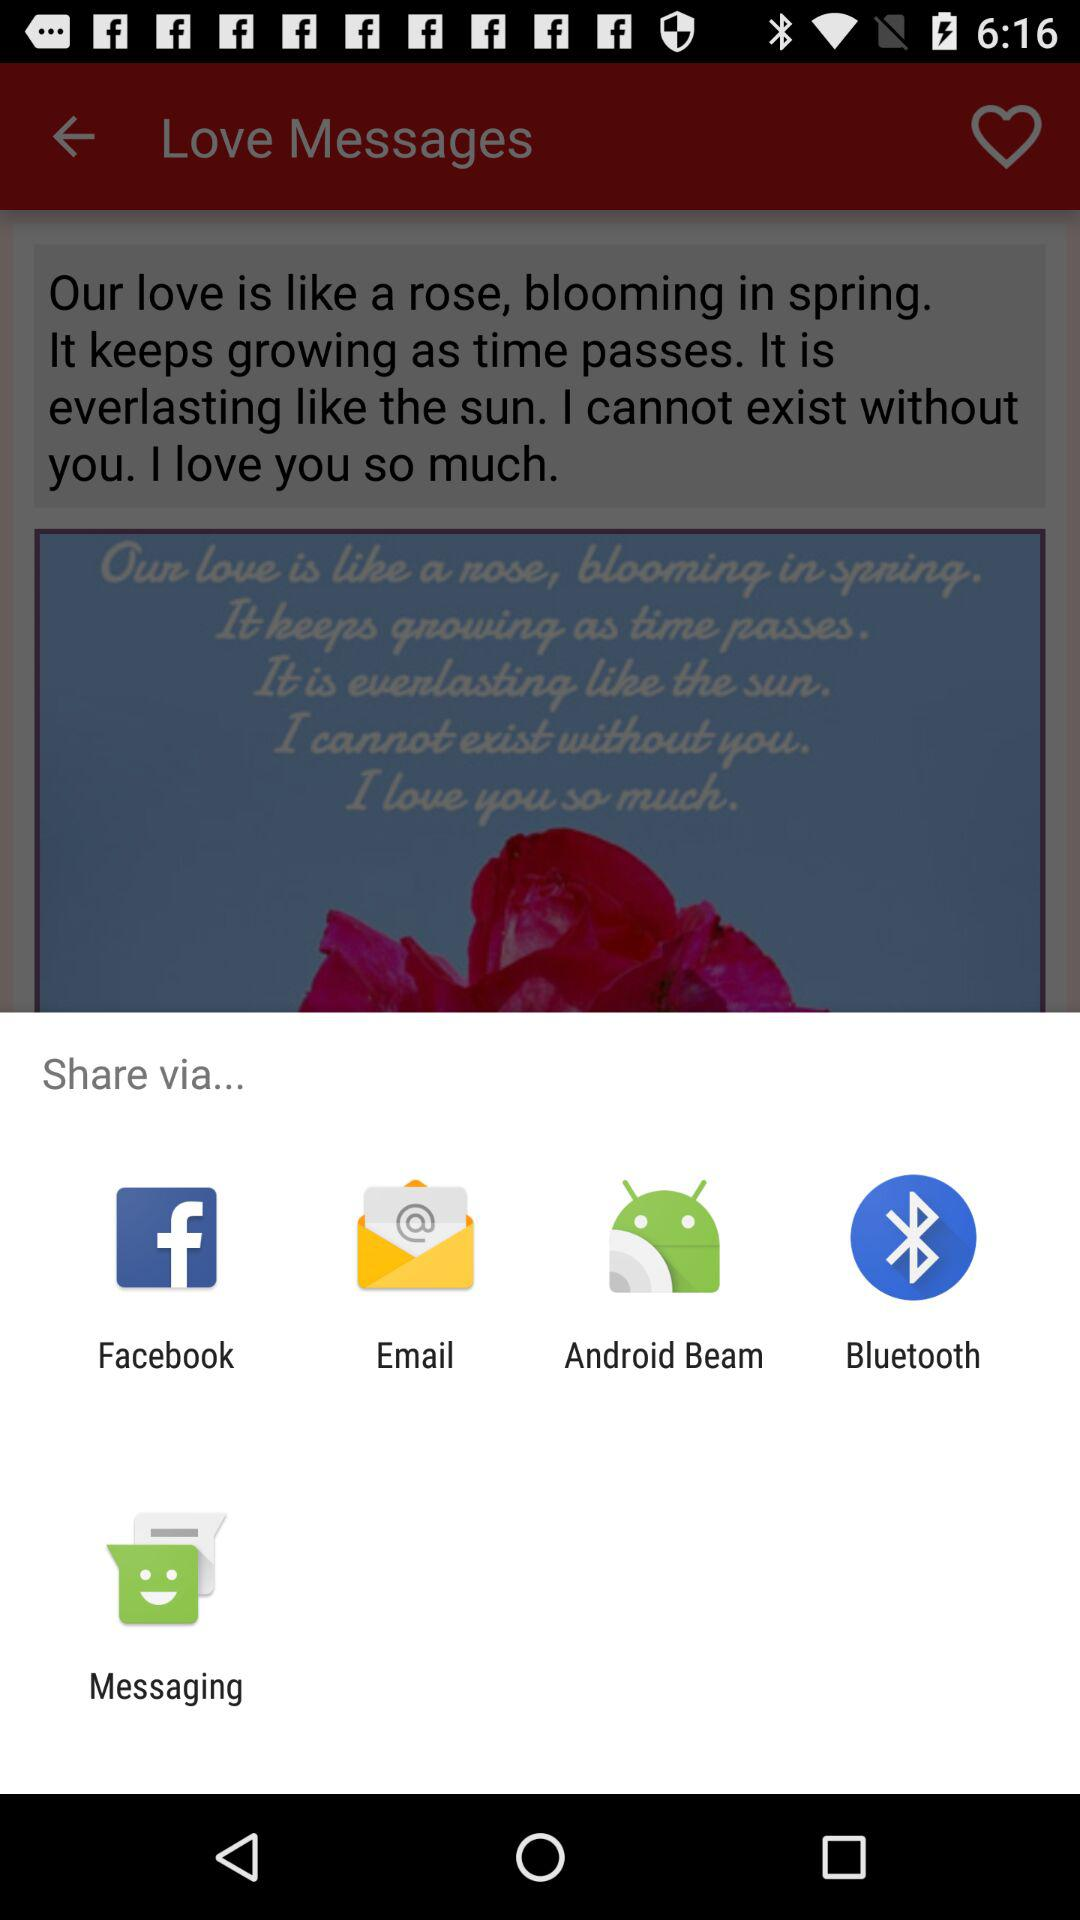What are the different options available for sharing love messages? The different options available are "Facebook", "Email", "Android Beam", "Bluetooth" and "Messaging". 